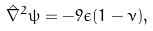<formula> <loc_0><loc_0><loc_500><loc_500>\hat { \nabla } ^ { 2 } \psi = - 9 \epsilon ( 1 - \nu ) ,</formula> 